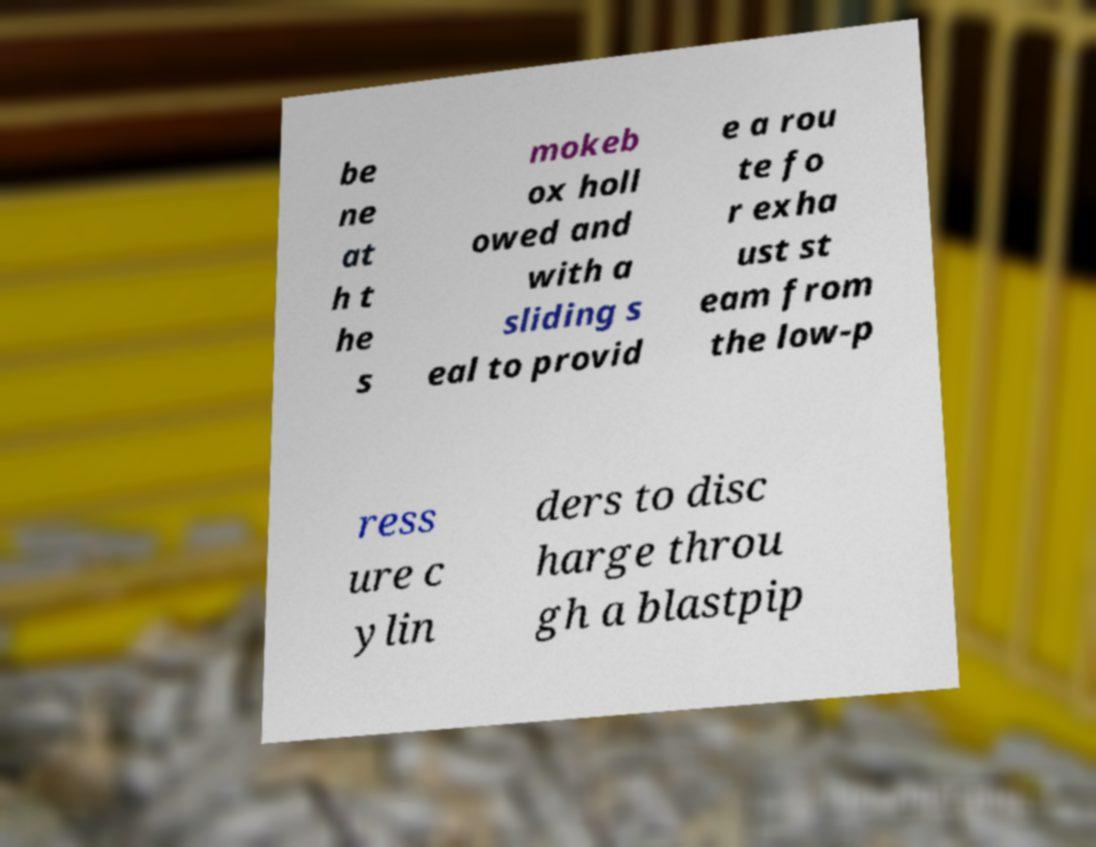I need the written content from this picture converted into text. Can you do that? be ne at h t he s mokeb ox holl owed and with a sliding s eal to provid e a rou te fo r exha ust st eam from the low-p ress ure c ylin ders to disc harge throu gh a blastpip 